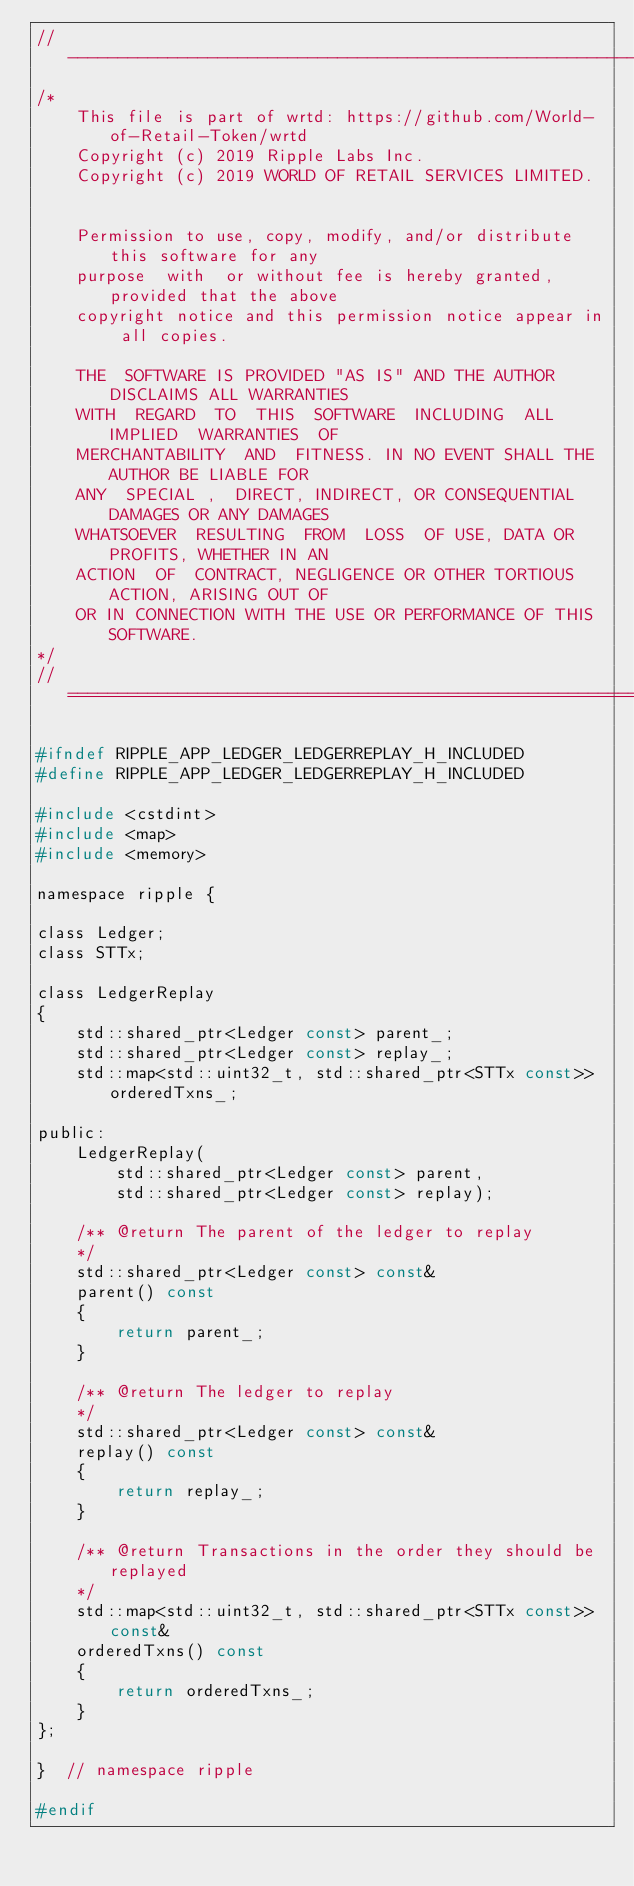Convert code to text. <code><loc_0><loc_0><loc_500><loc_500><_C_>//------------------------------------------------------------------------------
/*
    This file is part of wrtd: https://github.com/World-of-Retail-Token/wrtd
    Copyright (c) 2019 Ripple Labs Inc.
    Copyright (c) 2019 WORLD OF RETAIL SERVICES LIMITED.


    Permission to use, copy, modify, and/or distribute this software for any
    purpose  with  or without fee is hereby granted, provided that the above
    copyright notice and this permission notice appear in all copies.

    THE  SOFTWARE IS PROVIDED "AS IS" AND THE AUTHOR DISCLAIMS ALL WARRANTIES
    WITH  REGARD  TO  THIS  SOFTWARE  INCLUDING  ALL  IMPLIED  WARRANTIES  OF
    MERCHANTABILITY  AND  FITNESS. IN NO EVENT SHALL THE AUTHOR BE LIABLE FOR
    ANY  SPECIAL ,  DIRECT, INDIRECT, OR CONSEQUENTIAL DAMAGES OR ANY DAMAGES
    WHATSOEVER  RESULTING  FROM  LOSS  OF USE, DATA OR PROFITS, WHETHER IN AN
    ACTION  OF  CONTRACT, NEGLIGENCE OR OTHER TORTIOUS ACTION, ARISING OUT OF
    OR IN CONNECTION WITH THE USE OR PERFORMANCE OF THIS SOFTWARE.
*/
//==============================================================================

#ifndef RIPPLE_APP_LEDGER_LEDGERREPLAY_H_INCLUDED
#define RIPPLE_APP_LEDGER_LEDGERREPLAY_H_INCLUDED

#include <cstdint>
#include <map>
#include <memory>

namespace ripple {

class Ledger;
class STTx;

class LedgerReplay
{
    std::shared_ptr<Ledger const> parent_;
    std::shared_ptr<Ledger const> replay_;
    std::map<std::uint32_t, std::shared_ptr<STTx const>> orderedTxns_;

public:
    LedgerReplay(
        std::shared_ptr<Ledger const> parent,
        std::shared_ptr<Ledger const> replay);

    /** @return The parent of the ledger to replay
    */
    std::shared_ptr<Ledger const> const&
    parent() const
    {
        return parent_;
    }

    /** @return The ledger to replay
    */
    std::shared_ptr<Ledger const> const&
    replay() const
    {
        return replay_;
    }

    /** @return Transactions in the order they should be replayed
    */
    std::map<std::uint32_t, std::shared_ptr<STTx const>> const&
    orderedTxns() const
    {
        return orderedTxns_;
    }
};

}  // namespace ripple

#endif
</code> 